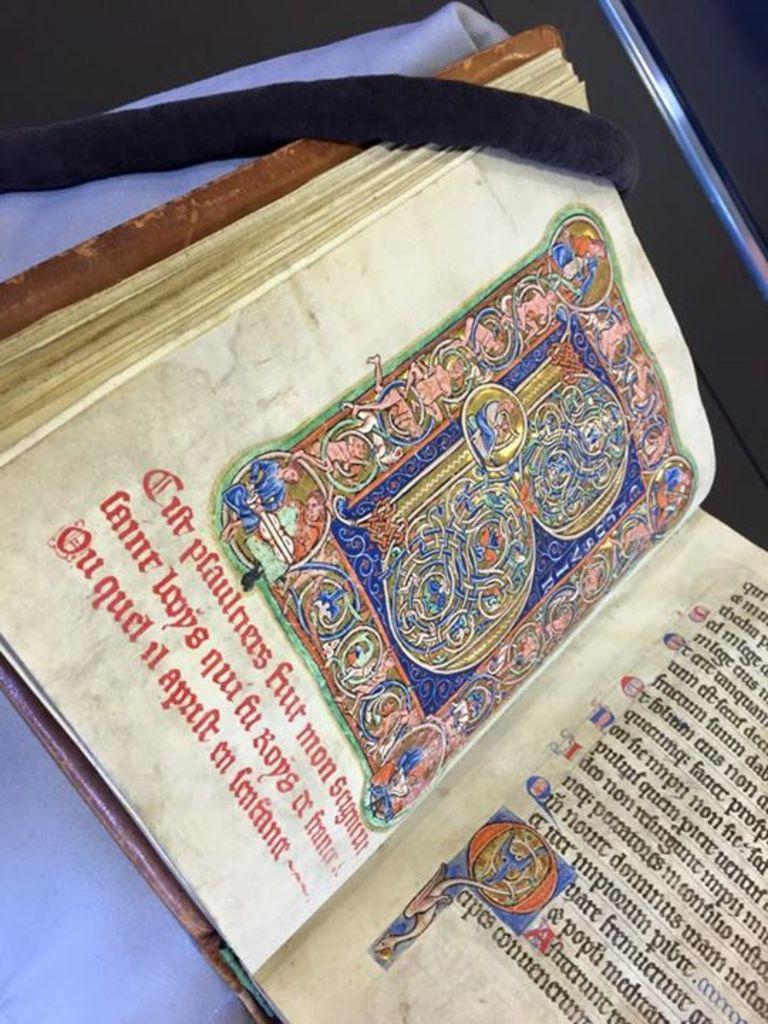What object is visible in the image? There is a book in the image. Where is the book located? The book is placed on a table. In which direction is the fowl facing in the image? There is no fowl present in the image, so it cannot be determined in which direction it might be facing. 